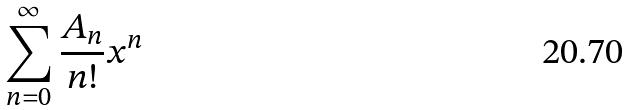Convert formula to latex. <formula><loc_0><loc_0><loc_500><loc_500>\sum _ { n = 0 } ^ { \infty } \frac { A _ { n } } { n ! } x ^ { n }</formula> 